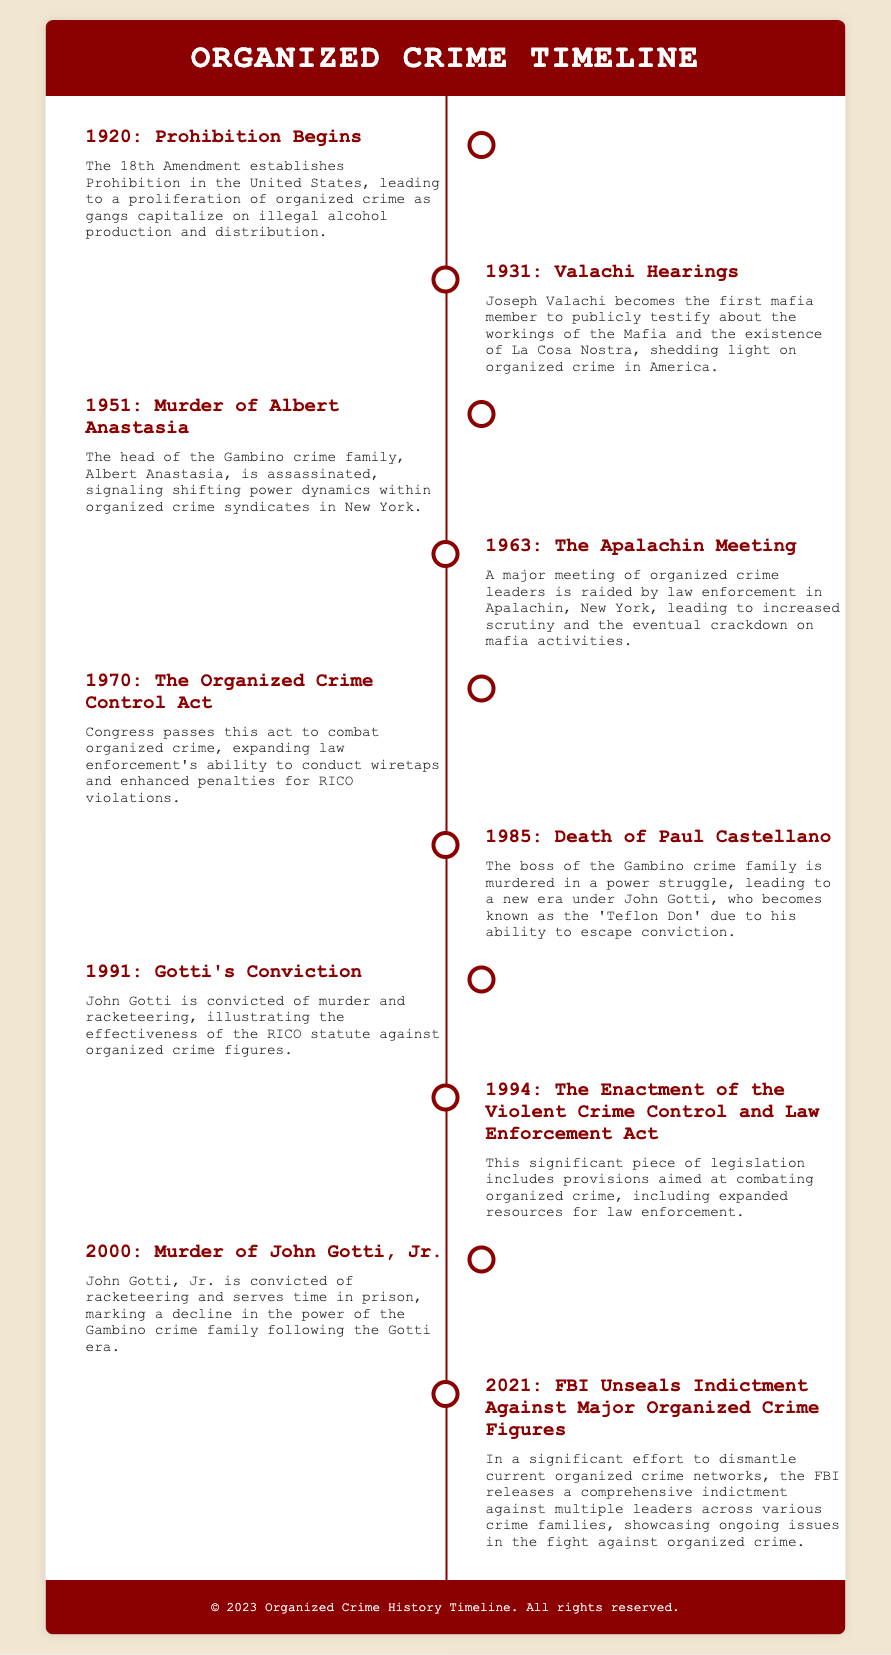What year did Prohibition begin? Prohibition began in 1920, as stated in the first event of the timeline.
Answer: 1920 Who testified about the workings of the Mafia in 1931? Joseph Valachi is mentioned as the first mafia member to testify publicly about the Mafia in 1931.
Answer: Joseph Valachi What major event occurred in 1963? The Apalachin Meeting was a significant event raided by law enforcement in 1963.
Answer: The Apalachin Meeting What does the RICO statute refer to? The RICO statute refers to legislation that was effectively used against organized crime figures, particularly noted in Gotti's conviction in 1991.
Answer: RICO statute How many significant events are listed in the timeline? Counting the events presented in the timeline, there are a total of ten significant events detailed.
Answer: 10 What was the outcome of the Apocalypse Meeting? The outcome of the Apalachin Meeting resulted in increased scrutiny and a crackdown on mafia activities.
Answer: Increased scrutiny What was the main focus of the Organized Crime Control Act passed in 1970? The main focus was to combat organized crime by expanding law enforcement's ability to conduct wiretaps.
Answer: Combating organized crime In what year was John Gotti convicted? John Gotti was convicted in 1991 for murder and racketeering, showcasing the effectiveness of the RICO statute.
Answer: 1991 What year did the FBI unseal indictments against organized crime figures? The FBI unsealed indictments against major organized crime figures in 2021, as noted in the final event.
Answer: 2021 Who became known as the 'Teflon Don'? John Gotti became known as the 'Teflon Don' due to his ability to escape conviction.
Answer: John Gotti 